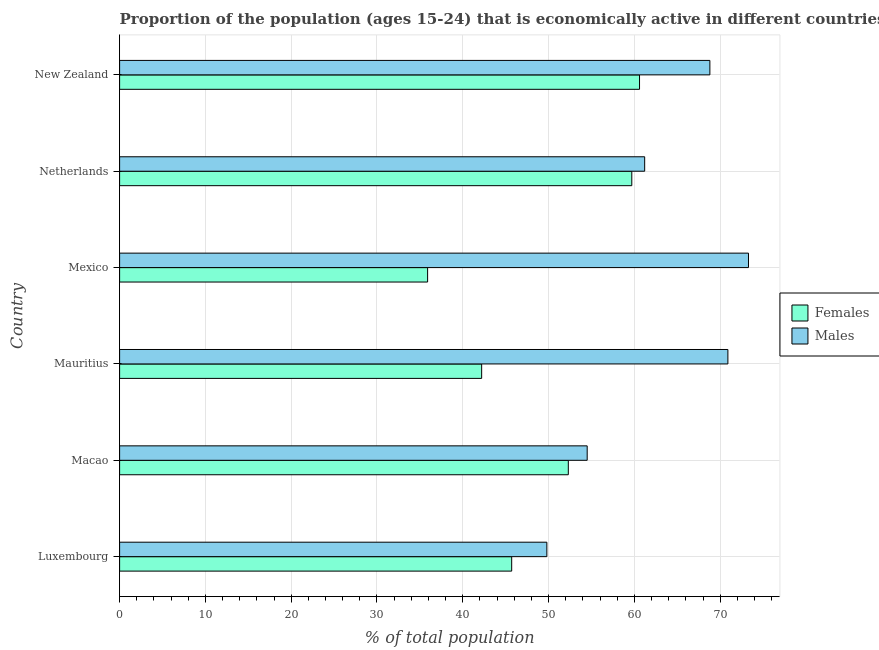How many different coloured bars are there?
Your answer should be very brief. 2. How many bars are there on the 2nd tick from the bottom?
Ensure brevity in your answer.  2. What is the label of the 5th group of bars from the top?
Provide a short and direct response. Macao. What is the percentage of economically active female population in Macao?
Your response must be concise. 52.3. Across all countries, what is the maximum percentage of economically active male population?
Offer a very short reply. 73.3. Across all countries, what is the minimum percentage of economically active female population?
Provide a short and direct response. 35.9. In which country was the percentage of economically active female population maximum?
Keep it short and to the point. New Zealand. In which country was the percentage of economically active male population minimum?
Keep it short and to the point. Luxembourg. What is the total percentage of economically active female population in the graph?
Your answer should be compact. 296.4. What is the difference between the percentage of economically active male population in Mexico and that in Netherlands?
Your answer should be compact. 12.1. What is the difference between the percentage of economically active female population in Netherlands and the percentage of economically active male population in Mauritius?
Provide a short and direct response. -11.2. What is the average percentage of economically active female population per country?
Give a very brief answer. 49.4. What is the difference between the percentage of economically active female population and percentage of economically active male population in Mauritius?
Provide a short and direct response. -28.7. What is the ratio of the percentage of economically active male population in Mauritius to that in Netherlands?
Your response must be concise. 1.16. What is the difference between the highest and the second highest percentage of economically active male population?
Your answer should be compact. 2.4. What is the difference between the highest and the lowest percentage of economically active male population?
Your response must be concise. 23.5. In how many countries, is the percentage of economically active female population greater than the average percentage of economically active female population taken over all countries?
Give a very brief answer. 3. What does the 1st bar from the top in Netherlands represents?
Provide a short and direct response. Males. What does the 1st bar from the bottom in Macao represents?
Your answer should be compact. Females. How many countries are there in the graph?
Your answer should be very brief. 6. What is the difference between two consecutive major ticks on the X-axis?
Give a very brief answer. 10. Are the values on the major ticks of X-axis written in scientific E-notation?
Offer a very short reply. No. Does the graph contain any zero values?
Make the answer very short. No. How many legend labels are there?
Ensure brevity in your answer.  2. What is the title of the graph?
Make the answer very short. Proportion of the population (ages 15-24) that is economically active in different countries. Does "Age 15+" appear as one of the legend labels in the graph?
Your answer should be very brief. No. What is the label or title of the X-axis?
Give a very brief answer. % of total population. What is the % of total population of Females in Luxembourg?
Ensure brevity in your answer.  45.7. What is the % of total population in Males in Luxembourg?
Keep it short and to the point. 49.8. What is the % of total population of Females in Macao?
Make the answer very short. 52.3. What is the % of total population in Males in Macao?
Provide a short and direct response. 54.5. What is the % of total population in Females in Mauritius?
Your answer should be very brief. 42.2. What is the % of total population in Males in Mauritius?
Give a very brief answer. 70.9. What is the % of total population of Females in Mexico?
Your answer should be very brief. 35.9. What is the % of total population in Males in Mexico?
Ensure brevity in your answer.  73.3. What is the % of total population of Females in Netherlands?
Offer a terse response. 59.7. What is the % of total population of Males in Netherlands?
Your response must be concise. 61.2. What is the % of total population of Females in New Zealand?
Your answer should be compact. 60.6. What is the % of total population in Males in New Zealand?
Offer a terse response. 68.8. Across all countries, what is the maximum % of total population of Females?
Offer a very short reply. 60.6. Across all countries, what is the maximum % of total population of Males?
Give a very brief answer. 73.3. Across all countries, what is the minimum % of total population of Females?
Your response must be concise. 35.9. Across all countries, what is the minimum % of total population of Males?
Offer a very short reply. 49.8. What is the total % of total population of Females in the graph?
Provide a succinct answer. 296.4. What is the total % of total population in Males in the graph?
Keep it short and to the point. 378.5. What is the difference between the % of total population of Females in Luxembourg and that in Macao?
Ensure brevity in your answer.  -6.6. What is the difference between the % of total population in Males in Luxembourg and that in Mauritius?
Make the answer very short. -21.1. What is the difference between the % of total population in Males in Luxembourg and that in Mexico?
Your answer should be very brief. -23.5. What is the difference between the % of total population in Females in Luxembourg and that in Netherlands?
Your answer should be very brief. -14. What is the difference between the % of total population in Females in Luxembourg and that in New Zealand?
Your answer should be compact. -14.9. What is the difference between the % of total population in Males in Luxembourg and that in New Zealand?
Keep it short and to the point. -19. What is the difference between the % of total population of Males in Macao and that in Mauritius?
Offer a terse response. -16.4. What is the difference between the % of total population of Males in Macao and that in Mexico?
Offer a very short reply. -18.8. What is the difference between the % of total population of Males in Macao and that in New Zealand?
Give a very brief answer. -14.3. What is the difference between the % of total population of Males in Mauritius and that in Mexico?
Make the answer very short. -2.4. What is the difference between the % of total population in Females in Mauritius and that in Netherlands?
Offer a terse response. -17.5. What is the difference between the % of total population of Females in Mauritius and that in New Zealand?
Offer a terse response. -18.4. What is the difference between the % of total population of Females in Mexico and that in Netherlands?
Your response must be concise. -23.8. What is the difference between the % of total population in Females in Mexico and that in New Zealand?
Your answer should be compact. -24.7. What is the difference between the % of total population in Females in Netherlands and that in New Zealand?
Your answer should be very brief. -0.9. What is the difference between the % of total population in Females in Luxembourg and the % of total population in Males in Mauritius?
Ensure brevity in your answer.  -25.2. What is the difference between the % of total population of Females in Luxembourg and the % of total population of Males in Mexico?
Keep it short and to the point. -27.6. What is the difference between the % of total population in Females in Luxembourg and the % of total population in Males in Netherlands?
Your answer should be compact. -15.5. What is the difference between the % of total population in Females in Luxembourg and the % of total population in Males in New Zealand?
Your response must be concise. -23.1. What is the difference between the % of total population in Females in Macao and the % of total population in Males in Mauritius?
Provide a succinct answer. -18.6. What is the difference between the % of total population of Females in Macao and the % of total population of Males in Mexico?
Keep it short and to the point. -21. What is the difference between the % of total population of Females in Macao and the % of total population of Males in New Zealand?
Provide a succinct answer. -16.5. What is the difference between the % of total population in Females in Mauritius and the % of total population in Males in Mexico?
Provide a succinct answer. -31.1. What is the difference between the % of total population of Females in Mauritius and the % of total population of Males in Netherlands?
Your answer should be compact. -19. What is the difference between the % of total population in Females in Mauritius and the % of total population in Males in New Zealand?
Keep it short and to the point. -26.6. What is the difference between the % of total population of Females in Mexico and the % of total population of Males in Netherlands?
Make the answer very short. -25.3. What is the difference between the % of total population in Females in Mexico and the % of total population in Males in New Zealand?
Keep it short and to the point. -32.9. What is the difference between the % of total population of Females in Netherlands and the % of total population of Males in New Zealand?
Provide a short and direct response. -9.1. What is the average % of total population in Females per country?
Your answer should be compact. 49.4. What is the average % of total population in Males per country?
Ensure brevity in your answer.  63.08. What is the difference between the % of total population of Females and % of total population of Males in Macao?
Ensure brevity in your answer.  -2.2. What is the difference between the % of total population in Females and % of total population in Males in Mauritius?
Make the answer very short. -28.7. What is the difference between the % of total population in Females and % of total population in Males in Mexico?
Offer a terse response. -37.4. What is the difference between the % of total population in Females and % of total population in Males in Netherlands?
Keep it short and to the point. -1.5. What is the difference between the % of total population in Females and % of total population in Males in New Zealand?
Ensure brevity in your answer.  -8.2. What is the ratio of the % of total population in Females in Luxembourg to that in Macao?
Your response must be concise. 0.87. What is the ratio of the % of total population of Males in Luxembourg to that in Macao?
Your response must be concise. 0.91. What is the ratio of the % of total population of Females in Luxembourg to that in Mauritius?
Offer a very short reply. 1.08. What is the ratio of the % of total population in Males in Luxembourg to that in Mauritius?
Make the answer very short. 0.7. What is the ratio of the % of total population in Females in Luxembourg to that in Mexico?
Your answer should be compact. 1.27. What is the ratio of the % of total population in Males in Luxembourg to that in Mexico?
Your response must be concise. 0.68. What is the ratio of the % of total population in Females in Luxembourg to that in Netherlands?
Offer a terse response. 0.77. What is the ratio of the % of total population of Males in Luxembourg to that in Netherlands?
Your response must be concise. 0.81. What is the ratio of the % of total population in Females in Luxembourg to that in New Zealand?
Provide a succinct answer. 0.75. What is the ratio of the % of total population in Males in Luxembourg to that in New Zealand?
Your response must be concise. 0.72. What is the ratio of the % of total population of Females in Macao to that in Mauritius?
Keep it short and to the point. 1.24. What is the ratio of the % of total population in Males in Macao to that in Mauritius?
Your answer should be very brief. 0.77. What is the ratio of the % of total population in Females in Macao to that in Mexico?
Your response must be concise. 1.46. What is the ratio of the % of total population of Males in Macao to that in Mexico?
Your answer should be compact. 0.74. What is the ratio of the % of total population in Females in Macao to that in Netherlands?
Your answer should be very brief. 0.88. What is the ratio of the % of total population in Males in Macao to that in Netherlands?
Your answer should be very brief. 0.89. What is the ratio of the % of total population in Females in Macao to that in New Zealand?
Provide a short and direct response. 0.86. What is the ratio of the % of total population in Males in Macao to that in New Zealand?
Offer a very short reply. 0.79. What is the ratio of the % of total population of Females in Mauritius to that in Mexico?
Offer a terse response. 1.18. What is the ratio of the % of total population of Males in Mauritius to that in Mexico?
Offer a very short reply. 0.97. What is the ratio of the % of total population of Females in Mauritius to that in Netherlands?
Your answer should be compact. 0.71. What is the ratio of the % of total population of Males in Mauritius to that in Netherlands?
Your response must be concise. 1.16. What is the ratio of the % of total population in Females in Mauritius to that in New Zealand?
Ensure brevity in your answer.  0.7. What is the ratio of the % of total population in Males in Mauritius to that in New Zealand?
Offer a very short reply. 1.03. What is the ratio of the % of total population of Females in Mexico to that in Netherlands?
Your response must be concise. 0.6. What is the ratio of the % of total population in Males in Mexico to that in Netherlands?
Your answer should be very brief. 1.2. What is the ratio of the % of total population of Females in Mexico to that in New Zealand?
Your answer should be very brief. 0.59. What is the ratio of the % of total population in Males in Mexico to that in New Zealand?
Provide a succinct answer. 1.07. What is the ratio of the % of total population in Females in Netherlands to that in New Zealand?
Provide a short and direct response. 0.99. What is the ratio of the % of total population of Males in Netherlands to that in New Zealand?
Your answer should be compact. 0.89. What is the difference between the highest and the second highest % of total population of Males?
Provide a short and direct response. 2.4. What is the difference between the highest and the lowest % of total population in Females?
Offer a very short reply. 24.7. What is the difference between the highest and the lowest % of total population in Males?
Ensure brevity in your answer.  23.5. 